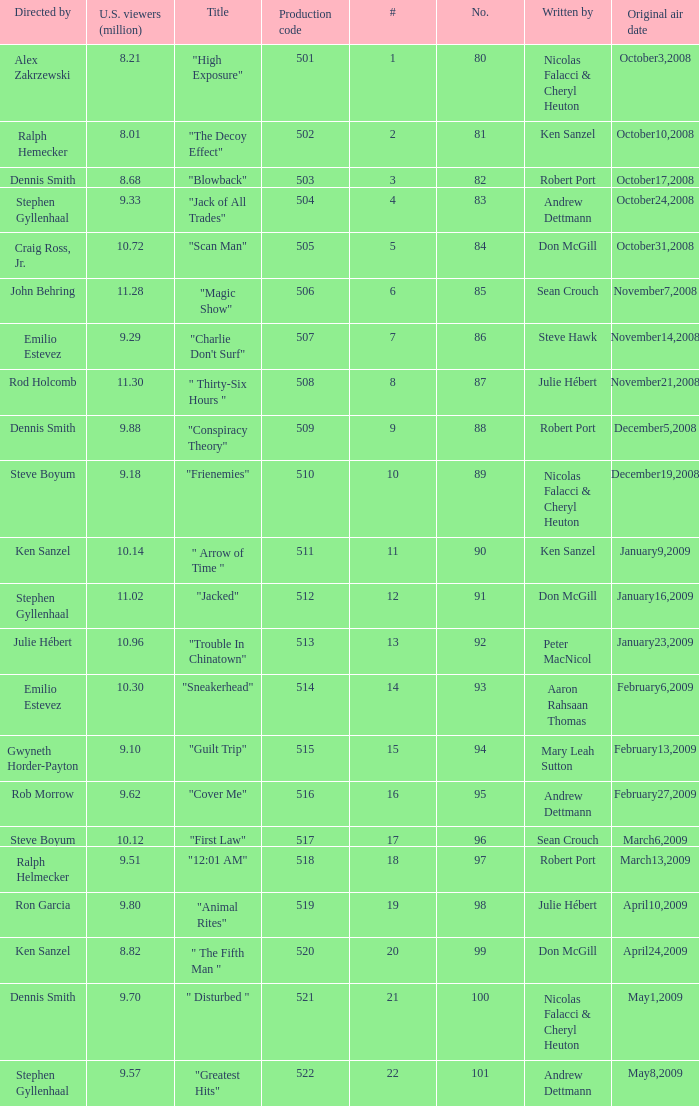What episode had 10.14 million viewers (U.S.)? 11.0. 